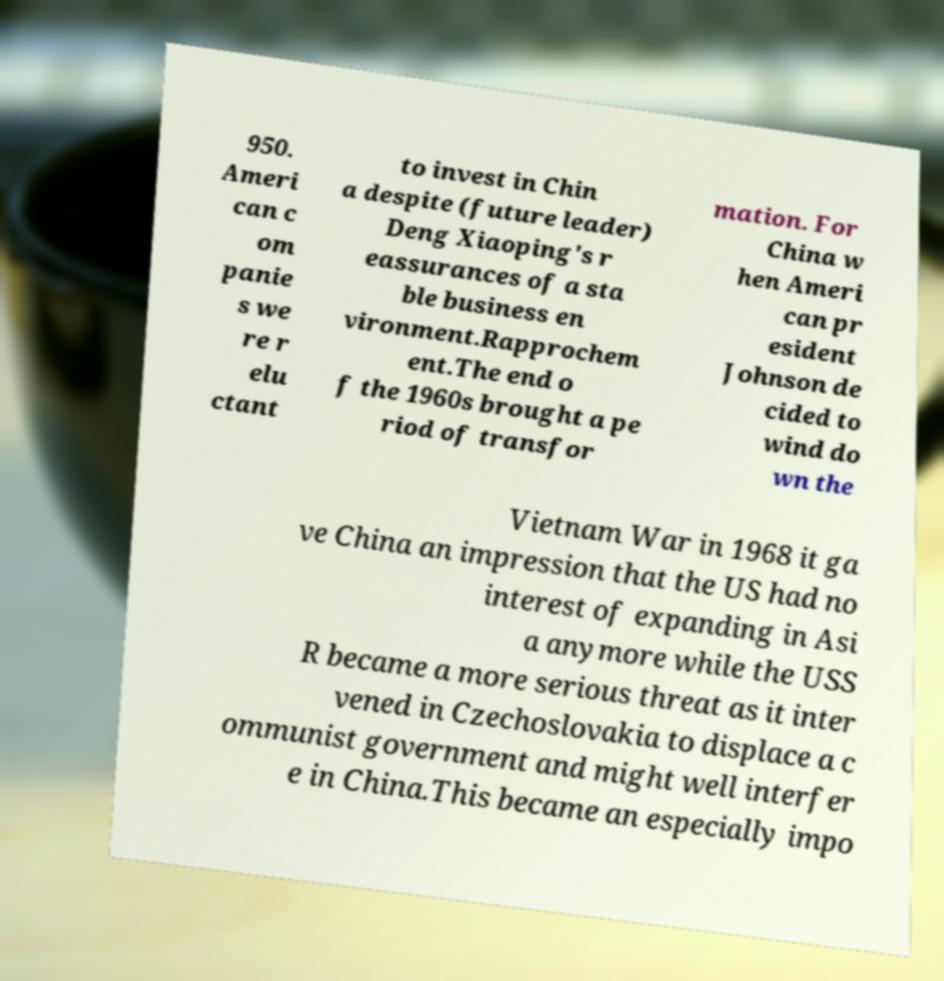Can you read and provide the text displayed in the image?This photo seems to have some interesting text. Can you extract and type it out for me? 950. Ameri can c om panie s we re r elu ctant to invest in Chin a despite (future leader) Deng Xiaoping's r eassurances of a sta ble business en vironment.Rapprochem ent.The end o f the 1960s brought a pe riod of transfor mation. For China w hen Ameri can pr esident Johnson de cided to wind do wn the Vietnam War in 1968 it ga ve China an impression that the US had no interest of expanding in Asi a anymore while the USS R became a more serious threat as it inter vened in Czechoslovakia to displace a c ommunist government and might well interfer e in China.This became an especially impo 